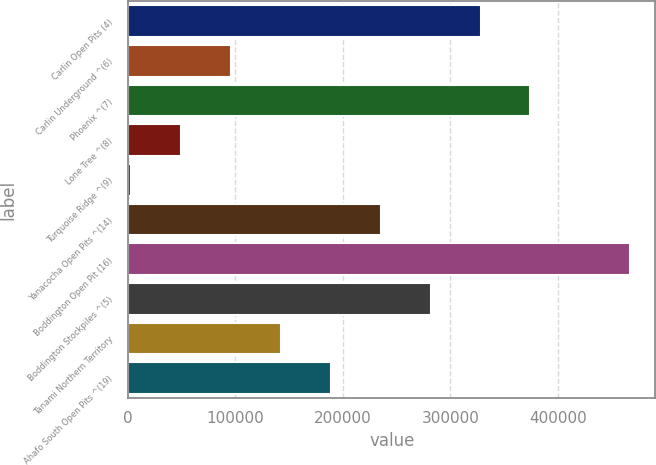Convert chart. <chart><loc_0><loc_0><loc_500><loc_500><bar_chart><fcel>Carlin Open Pits (4)<fcel>Carlin Underground ^(6)<fcel>Phoenix ^(7)<fcel>Lone Tree ^(8)<fcel>Turquoise Ridge ^(9)<fcel>Yanacocha Open Pits ^(14)<fcel>Boddington Open Pit (16)<fcel>Boddington Stockpiles ^(5)<fcel>Tanami Northern Territory<fcel>Ahafo South Open Pits ^(19)<nl><fcel>328190<fcel>95840<fcel>374660<fcel>49370<fcel>2900<fcel>235250<fcel>467600<fcel>281720<fcel>142310<fcel>188780<nl></chart> 